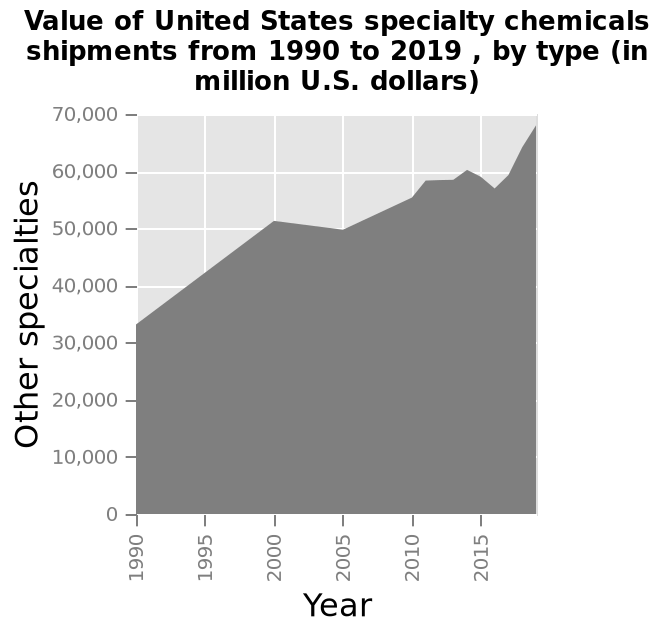<image>
please summary the statistics and relations of the chart Between 1990 and 2019 there has been an overall considerable rise in specialities from approximately 33,000 to just under 70,000. During the years 2005 and 2015 there was a dip in shipments but both times the trend recovered and continued to rise. What is the scale on the x-axis for the United States specialty chemicals shipments graph? The scale on the x-axis for the United States specialty chemicals shipments graph is linear and ranges from 1990 to 2015. Did the number of specialties recover after the dip in shipments?  Yes, both times the trend recovered and continued to rise. 